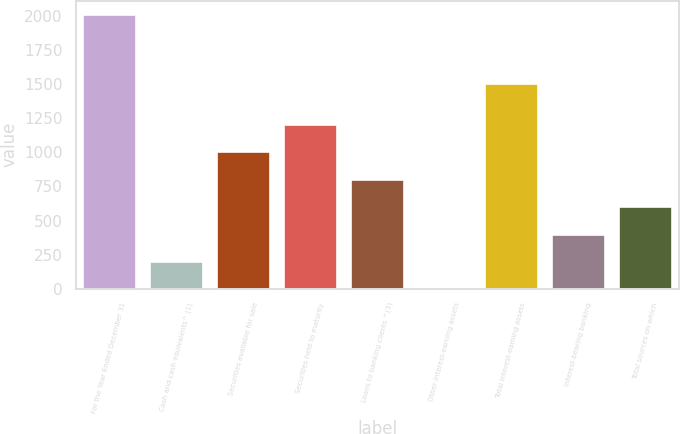Convert chart. <chart><loc_0><loc_0><loc_500><loc_500><bar_chart><fcel>For the Year Ended December 31<fcel>Cash and cash equivalents^ (1)<fcel>Securities available for sale<fcel>Securities held to maturity<fcel>Loans to banking clients ^(3)<fcel>Other interest-earning assets<fcel>Total interest-earning assets<fcel>Interest-bearing banking<fcel>Total sources on which<nl><fcel>2013<fcel>203.1<fcel>1007.5<fcel>1208.6<fcel>806.4<fcel>2<fcel>1513<fcel>404.2<fcel>605.3<nl></chart> 